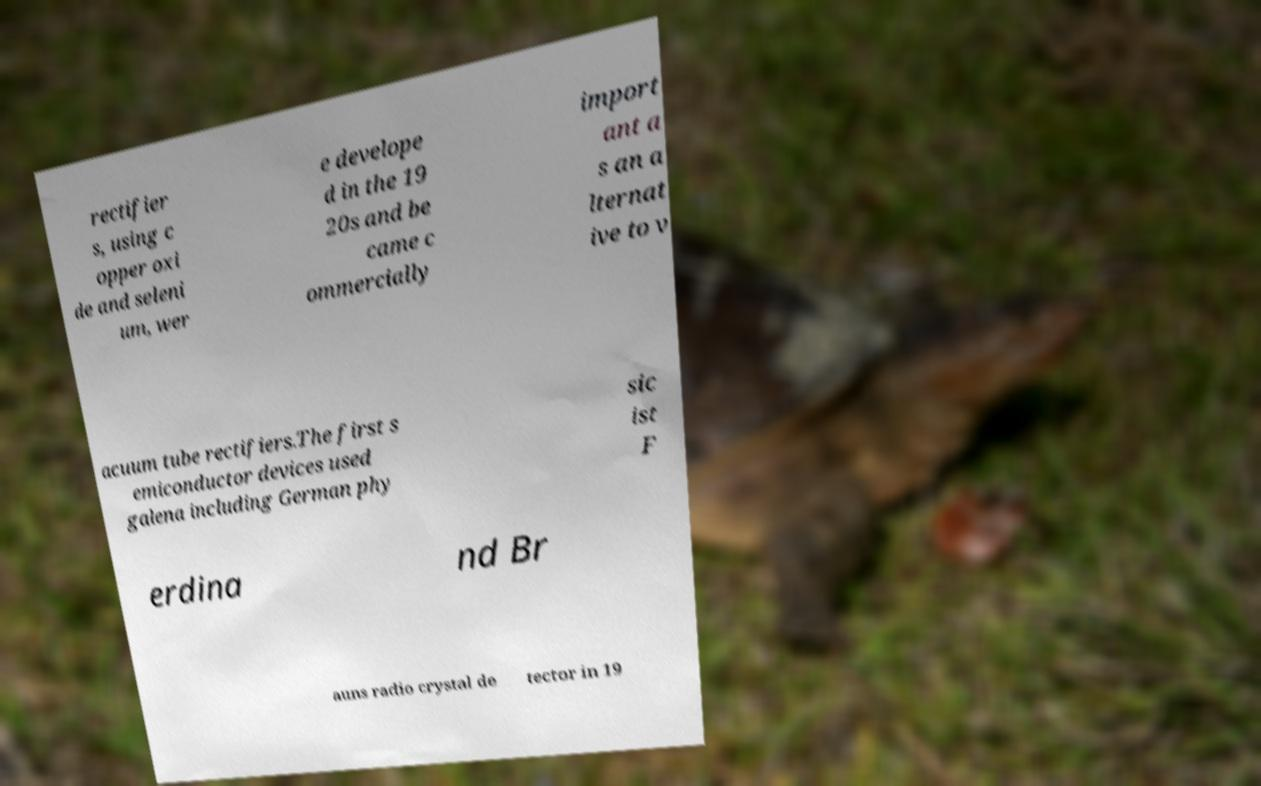I need the written content from this picture converted into text. Can you do that? rectifier s, using c opper oxi de and seleni um, wer e develope d in the 19 20s and be came c ommercially import ant a s an a lternat ive to v acuum tube rectifiers.The first s emiconductor devices used galena including German phy sic ist F erdina nd Br auns radio crystal de tector in 19 